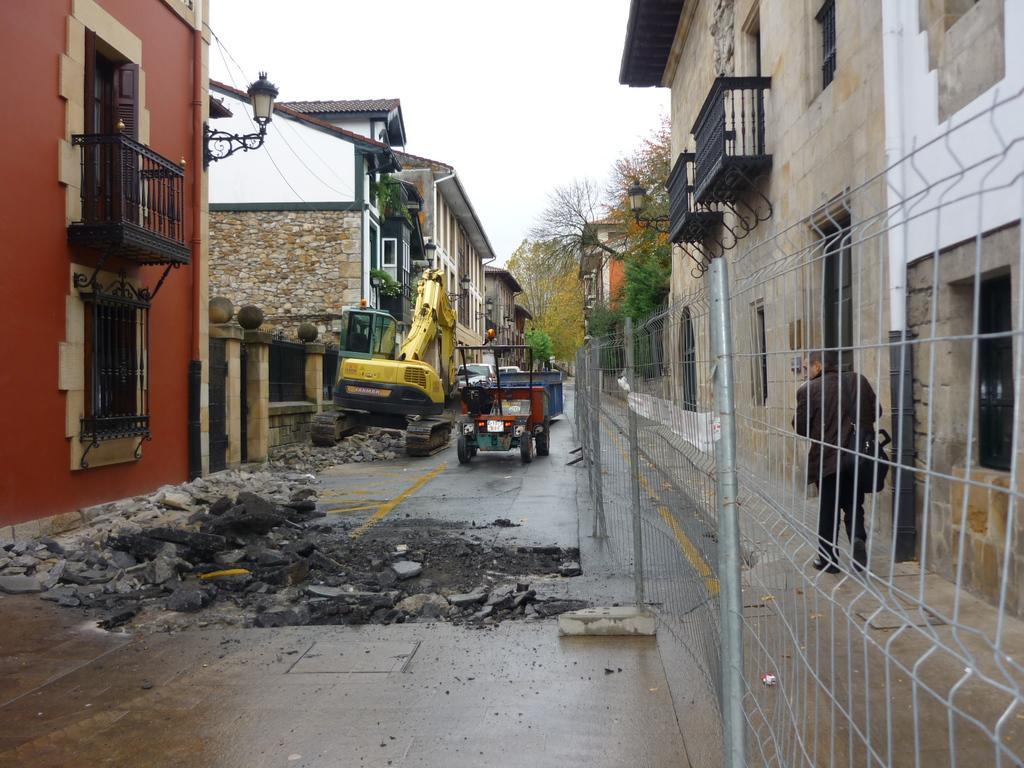Can you describe this image briefly? In the center of the image we can see vehicles. On the right there is a man. In the background there are buildings, trees and sky. We can see a mesh. 